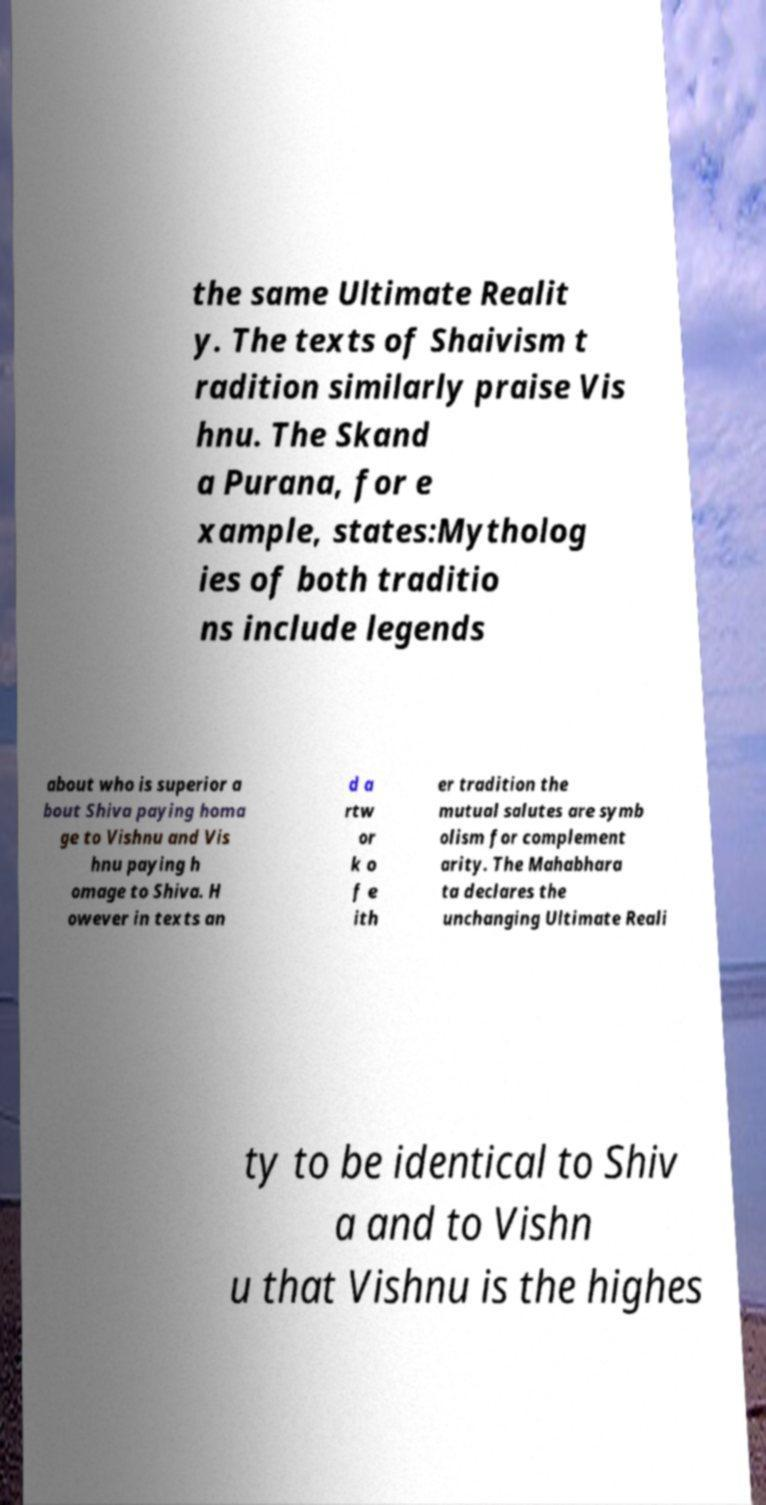Can you accurately transcribe the text from the provided image for me? the same Ultimate Realit y. The texts of Shaivism t radition similarly praise Vis hnu. The Skand a Purana, for e xample, states:Mytholog ies of both traditio ns include legends about who is superior a bout Shiva paying homa ge to Vishnu and Vis hnu paying h omage to Shiva. H owever in texts an d a rtw or k o f e ith er tradition the mutual salutes are symb olism for complement arity. The Mahabhara ta declares the unchanging Ultimate Reali ty to be identical to Shiv a and to Vishn u that Vishnu is the highes 